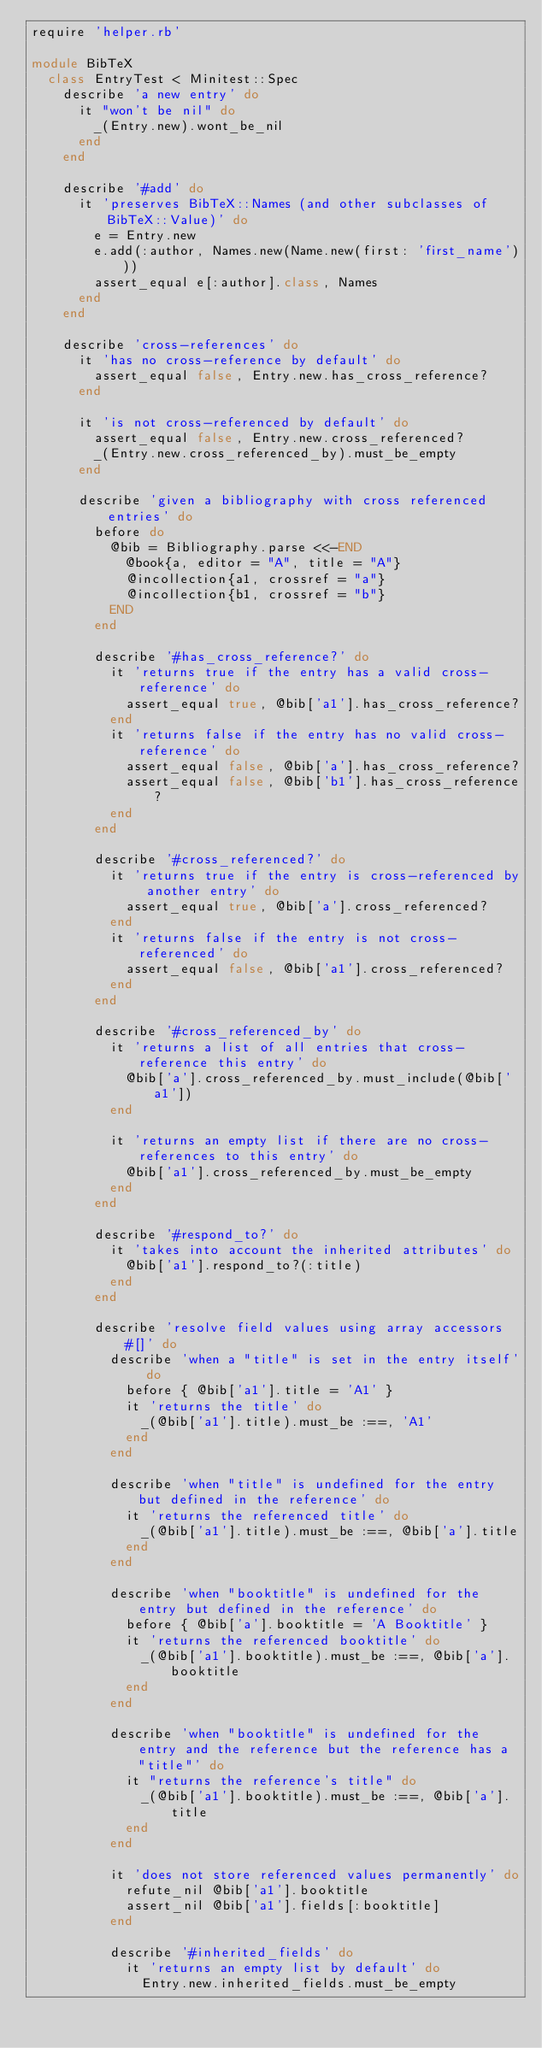Convert code to text. <code><loc_0><loc_0><loc_500><loc_500><_Ruby_>require 'helper.rb'

module BibTeX
  class EntryTest < Minitest::Spec
    describe 'a new entry' do
      it "won't be nil" do
        _(Entry.new).wont_be_nil
      end
    end

    describe '#add' do
      it 'preserves BibTeX::Names (and other subclasses of BibTeX::Value)' do
        e = Entry.new
        e.add(:author, Names.new(Name.new(first: 'first_name')))
        assert_equal e[:author].class, Names
      end
    end

    describe 'cross-references' do
      it 'has no cross-reference by default' do
        assert_equal false, Entry.new.has_cross_reference?
      end

      it 'is not cross-referenced by default' do
        assert_equal false, Entry.new.cross_referenced?
        _(Entry.new.cross_referenced_by).must_be_empty
      end

      describe 'given a bibliography with cross referenced entries' do
        before do
          @bib = Bibliography.parse <<-END
            @book{a, editor = "A", title = "A"}
            @incollection{a1, crossref = "a"}
            @incollection{b1, crossref = "b"}
          END
        end

        describe '#has_cross_reference?' do
          it 'returns true if the entry has a valid cross-reference' do
            assert_equal true, @bib['a1'].has_cross_reference?
          end
          it 'returns false if the entry has no valid cross-reference' do
            assert_equal false, @bib['a'].has_cross_reference?
            assert_equal false, @bib['b1'].has_cross_reference?
          end
        end

        describe '#cross_referenced?' do
          it 'returns true if the entry is cross-referenced by another entry' do
            assert_equal true, @bib['a'].cross_referenced?
          end
          it 'returns false if the entry is not cross-referenced' do
            assert_equal false, @bib['a1'].cross_referenced?
          end
        end

        describe '#cross_referenced_by' do
          it 'returns a list of all entries that cross-reference this entry' do
            @bib['a'].cross_referenced_by.must_include(@bib['a1'])
          end

          it 'returns an empty list if there are no cross-references to this entry' do
            @bib['a1'].cross_referenced_by.must_be_empty
          end
        end

        describe '#respond_to?' do
          it 'takes into account the inherited attributes' do
            @bib['a1'].respond_to?(:title)
          end
        end

        describe 'resolve field values using array accessors #[]' do
          describe 'when a "title" is set in the entry itself' do
            before { @bib['a1'].title = 'A1' }
            it 'returns the title' do
              _(@bib['a1'].title).must_be :==, 'A1'
            end
          end

          describe 'when "title" is undefined for the entry but defined in the reference' do
            it 'returns the referenced title' do
              _(@bib['a1'].title).must_be :==, @bib['a'].title
            end
          end

          describe 'when "booktitle" is undefined for the entry but defined in the reference' do
            before { @bib['a'].booktitle = 'A Booktitle' }
            it 'returns the referenced booktitle' do
              _(@bib['a1'].booktitle).must_be :==, @bib['a'].booktitle
            end
          end

          describe 'when "booktitle" is undefined for the entry and the reference but the reference has a "title"' do
            it "returns the reference's title" do
              _(@bib['a1'].booktitle).must_be :==, @bib['a'].title
            end
          end

          it 'does not store referenced values permanently' do
            refute_nil @bib['a1'].booktitle
            assert_nil @bib['a1'].fields[:booktitle]
          end

          describe '#inherited_fields' do
            it 'returns an empty list by default' do
              Entry.new.inherited_fields.must_be_empty</code> 